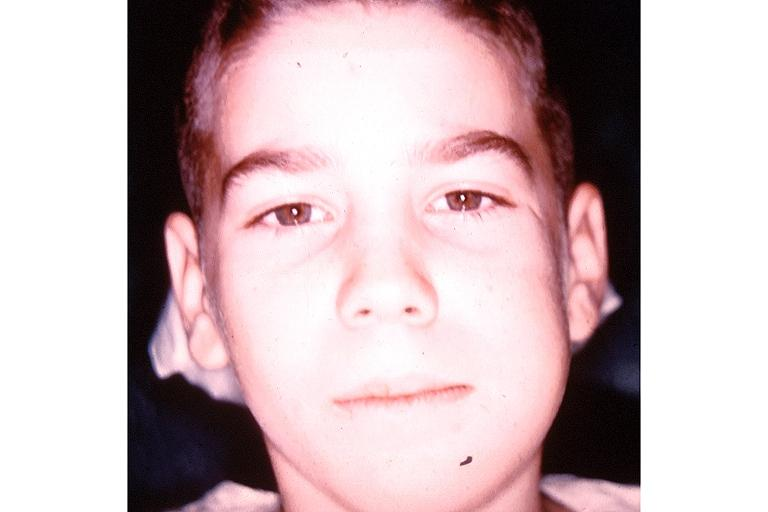what is present?
Answer the question using a single word or phrase. Oral 